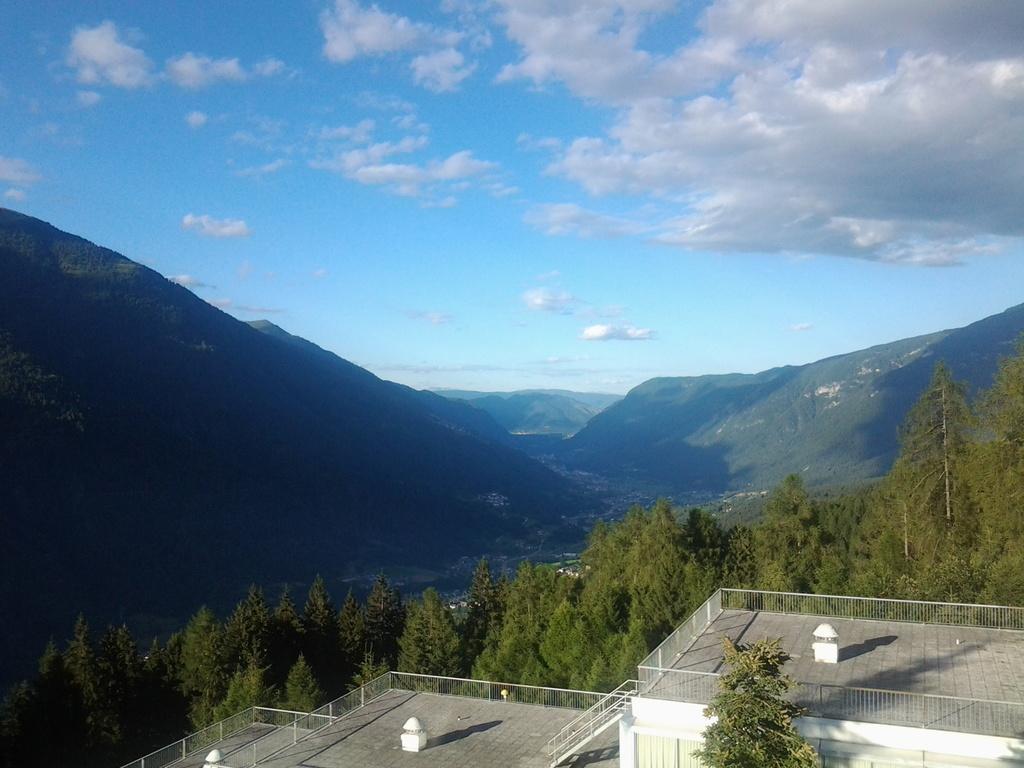Can you describe this image briefly? In this image I can see building, number of trees and in background I can see mountains, clouds and the sky. I can also see shadow over here. 